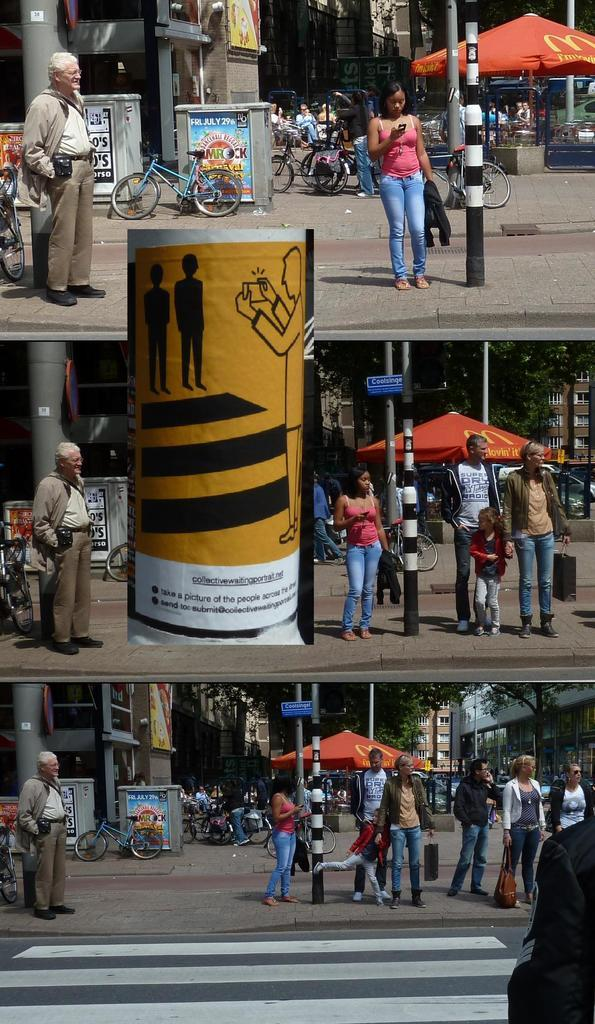Provide a one-sentence caption for the provided image. A city street with numerous people and an advertisement for Jamrock on Friday July 29th. 